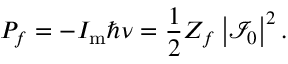Convert formula to latex. <formula><loc_0><loc_0><loc_500><loc_500>P _ { f } = - I _ { m } \hbar { \nu } = \frac { 1 } { 2 } Z _ { f } \left | \mathcal { I } _ { 0 } \right | ^ { 2 } .</formula> 